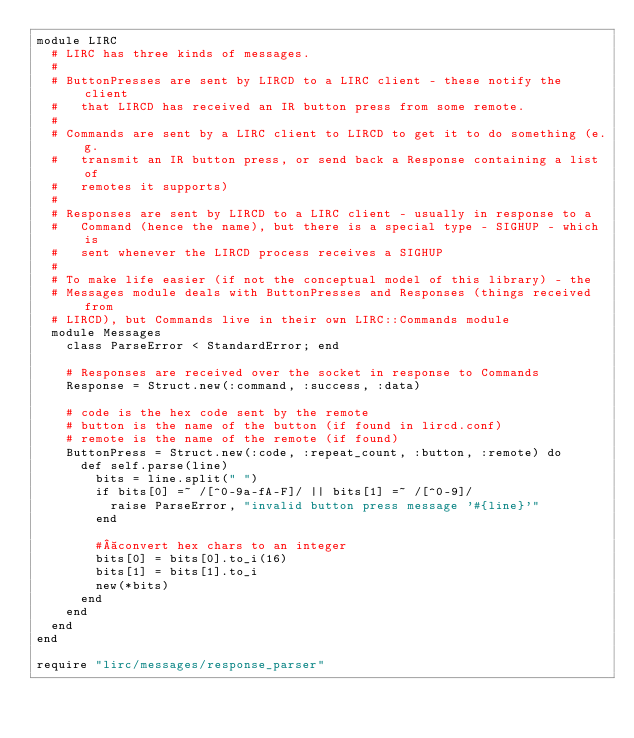Convert code to text. <code><loc_0><loc_0><loc_500><loc_500><_Ruby_>module LIRC
  # LIRC has three kinds of messages.
  #
  # ButtonPresses are sent by LIRCD to a LIRC client - these notify the client
  #   that LIRCD has received an IR button press from some remote.
  #
  # Commands are sent by a LIRC client to LIRCD to get it to do something (e.g.
  #   transmit an IR button press, or send back a Response containing a list of
  #   remotes it supports)
  #
  # Responses are sent by LIRCD to a LIRC client - usually in response to a
  #   Command (hence the name), but there is a special type - SIGHUP - which is
  #   sent whenever the LIRCD process receives a SIGHUP
  #
  # To make life easier (if not the conceptual model of this library) - the
  # Messages module deals with ButtonPresses and Responses (things received from
  # LIRCD), but Commands live in their own LIRC::Commands module
  module Messages
    class ParseError < StandardError; end

    # Responses are received over the socket in response to Commands
    Response = Struct.new(:command, :success, :data)

    # code is the hex code sent by the remote
    # button is the name of the button (if found in lircd.conf)
    # remote is the name of the remote (if found)
    ButtonPress = Struct.new(:code, :repeat_count, :button, :remote) do
      def self.parse(line)
        bits = line.split(" ")
        if bits[0] =~ /[^0-9a-fA-F]/ || bits[1] =~ /[^0-9]/
          raise ParseError, "invalid button press message '#{line}'"
        end

        # convert hex chars to an integer
        bits[0] = bits[0].to_i(16)
        bits[1] = bits[1].to_i
        new(*bits)
      end
    end
  end
end

require "lirc/messages/response_parser"
</code> 